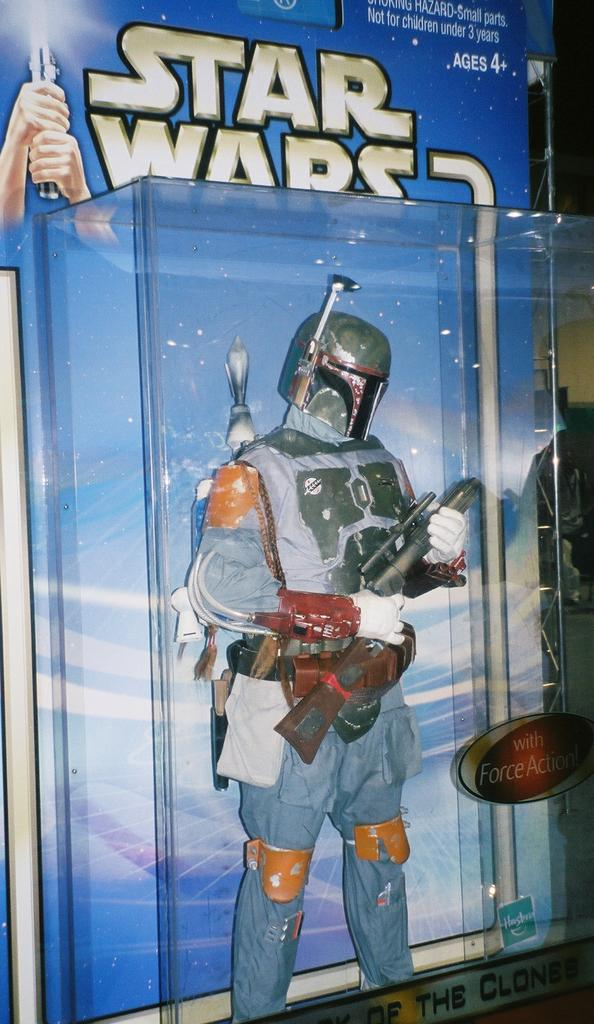What object can be seen in the image? There is a toy in the image. What is the toy holding in its hand? The toy is holding a gun in its hand. What protective gear is present in the image? There is a helmet in the image. How is the toy stored or contained in the image? The toy is packed in a plastic box. What color is the background of the image? The background of the image is blue. Can you see the maid cleaning the wax off the floor in the image? There is no maid or wax present in the image; it features a toy holding a gun, a helmet, and a blue background. 